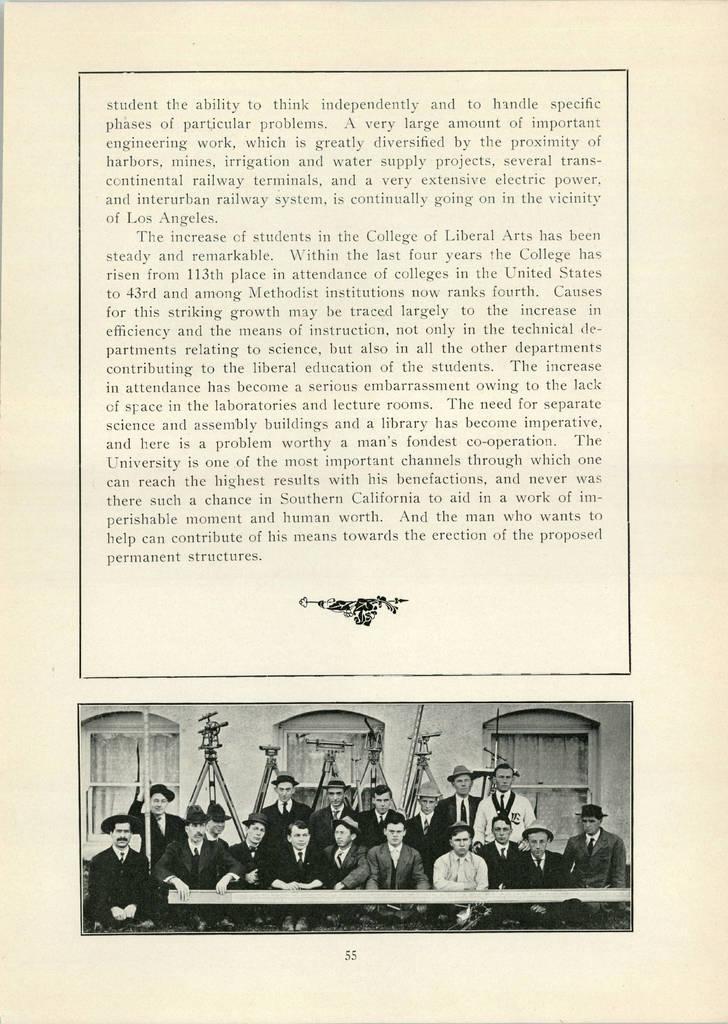How would you summarize this image in a sentence or two? In this image there is one paper, on the paper there is some text, and at the bottom of the paper there are some persons, wall, windows and some objects. 